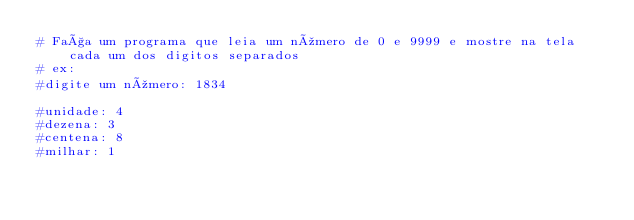Convert code to text. <code><loc_0><loc_0><loc_500><loc_500><_Python_># Faça um programa que leia um número de 0 e 9999 e mostre na tela cada um dos digitos separados
# ex:
#digite um número: 1834

#unidade: 4
#dezena: 3
#centena: 8
#milhar: 1</code> 